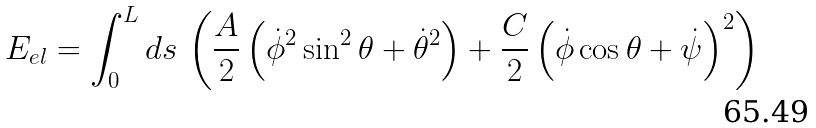Convert formula to latex. <formula><loc_0><loc_0><loc_500><loc_500>E _ { e l } = \int _ { 0 } ^ { L } d s \, \left ( \frac { A } { 2 } \left ( \dot { \phi } ^ { 2 } \sin ^ { 2 } \theta + \dot { \theta } ^ { 2 } \right ) + \frac { C } { 2 } \left ( \dot { \phi } \cos \theta + \dot { \psi } \right ) ^ { 2 } \right )</formula> 